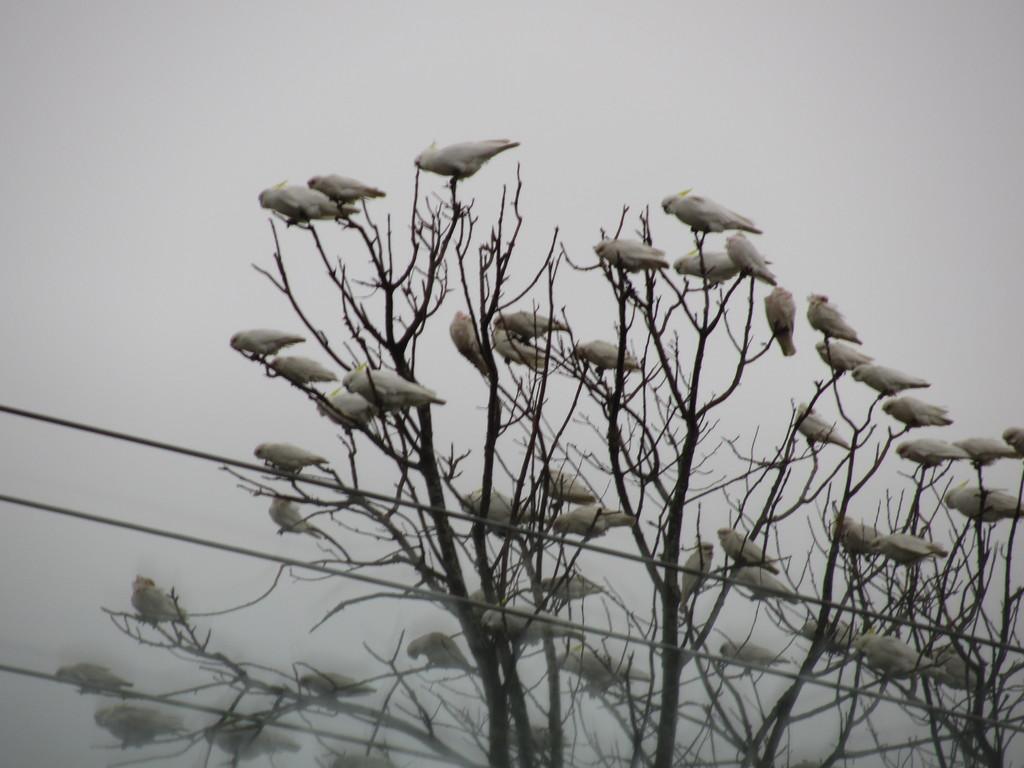Can you describe this image briefly? In this image there are birds on the trees. Bottom of the image there are wires. Background there is sky. 